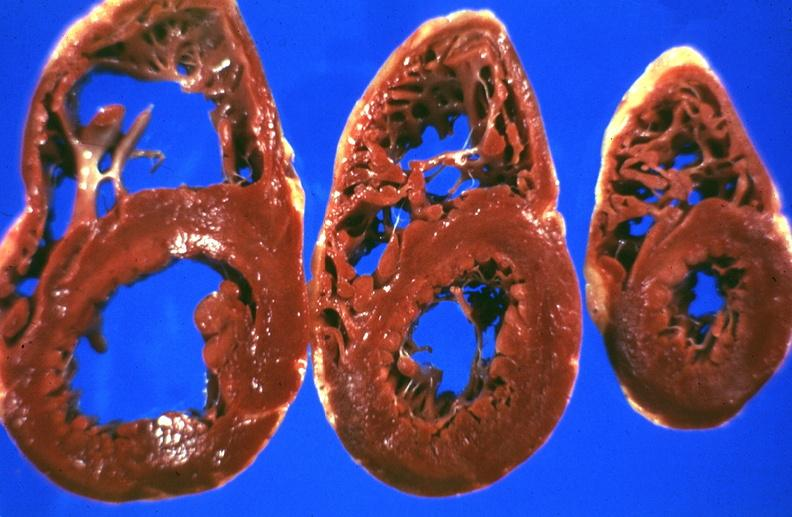what is present?
Answer the question using a single word or phrase. Hepatobiliary 